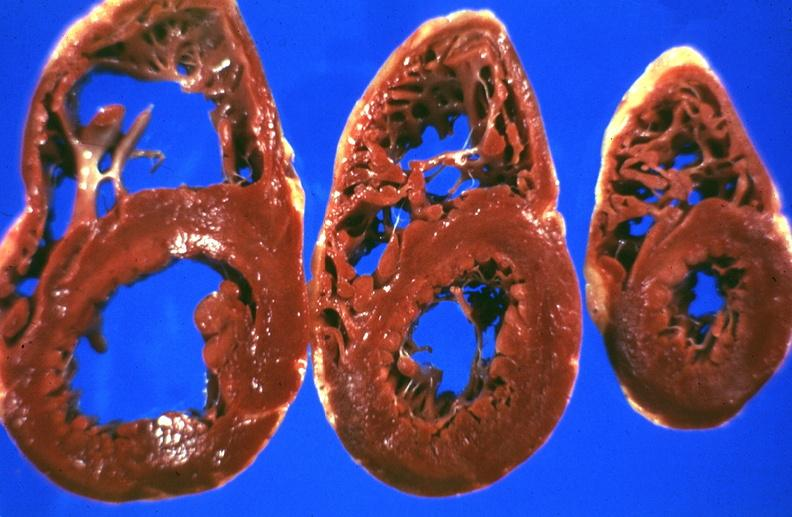what is present?
Answer the question using a single word or phrase. Hepatobiliary 